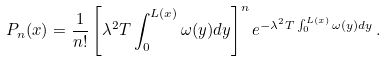Convert formula to latex. <formula><loc_0><loc_0><loc_500><loc_500>P _ { n } ( x ) = \frac { 1 } { n ! } \left [ \lambda ^ { 2 } T \int ^ { L ( x ) } _ { 0 } \omega ( y ) d y \right ] ^ { n } e ^ { - \lambda ^ { 2 } T \int ^ { L ( x ) } _ { 0 } \omega ( y ) d y } \, .</formula> 